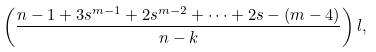<formula> <loc_0><loc_0><loc_500><loc_500>\left ( \frac { n - 1 + 3 s ^ { m - 1 } + 2 s ^ { m - 2 } + \cdots + 2 s - ( m - 4 ) } { n - k } \right ) l ,</formula> 